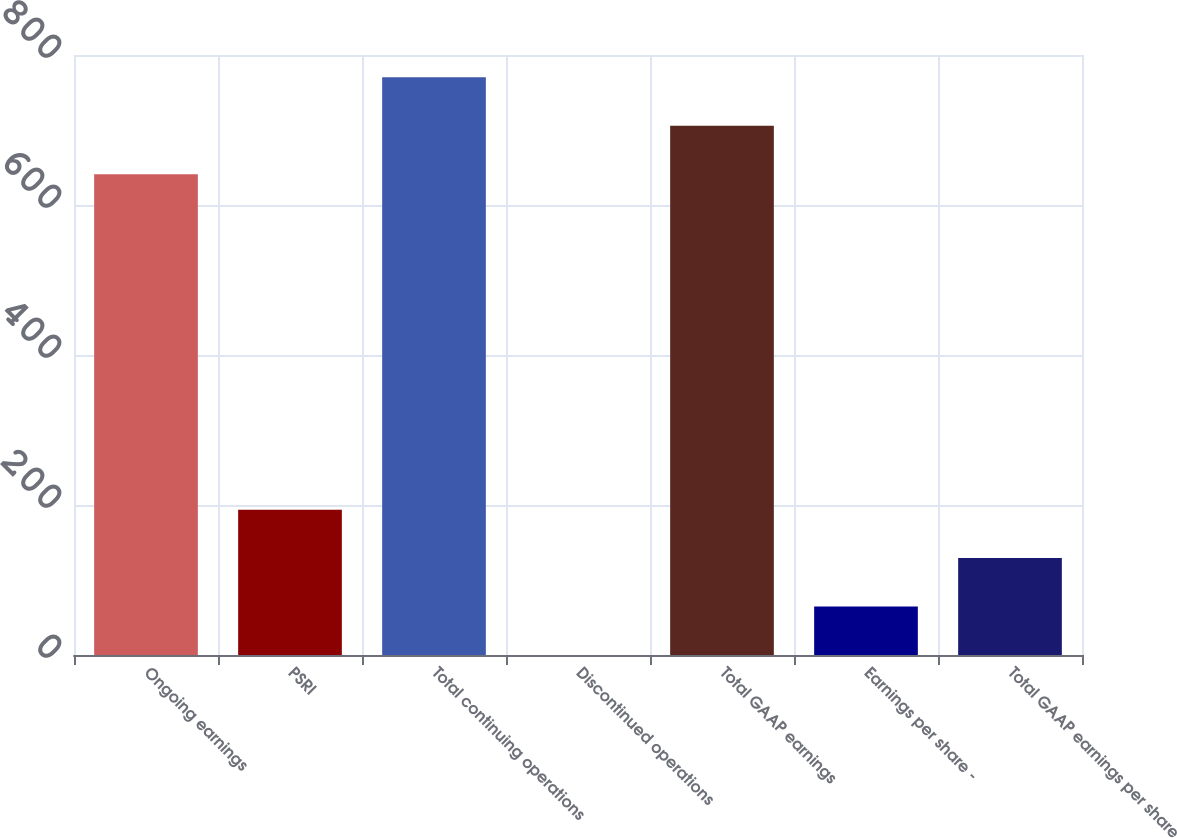Convert chart. <chart><loc_0><loc_0><loc_500><loc_500><bar_chart><fcel>Ongoing earnings<fcel>PSRI<fcel>Total continuing operations<fcel>Discontinued operations<fcel>Total GAAP earnings<fcel>Earnings per share -<fcel>Total GAAP earnings per share<nl><fcel>641.1<fcel>193.78<fcel>770.22<fcel>0.1<fcel>705.66<fcel>64.66<fcel>129.22<nl></chart> 